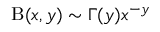<formula> <loc_0><loc_0><loc_500><loc_500>B ( x , y ) \sim \Gamma ( y ) x ^ { - y }</formula> 